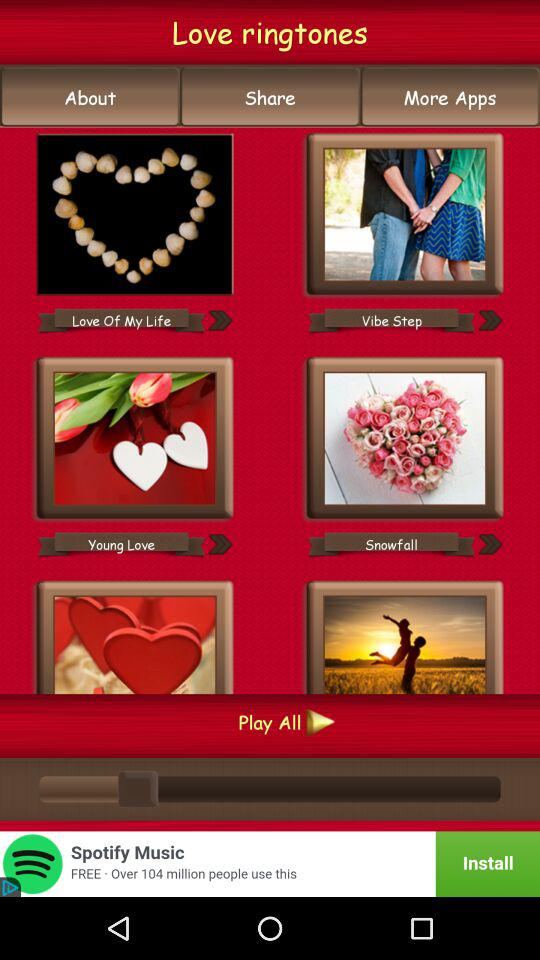What is the name of the application? The name of the application is "Love ringtones". 